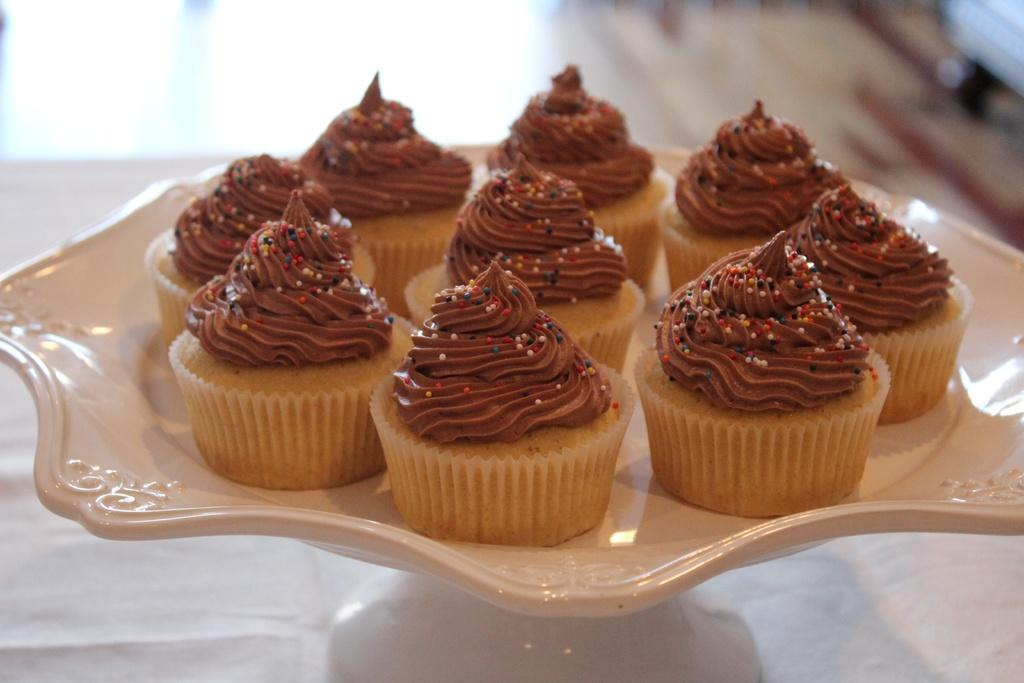What type of food is on the plate in the image? There are pancakes in a plate in the image. Where is the plate with pancakes located? The plate is on a table. Can you describe the background of the image? The background of the image is blurred. What type of fruit is hanging from the pocket in the image? There is no pocket or fruit present in the image. 